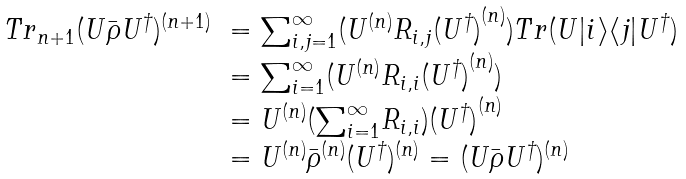<formula> <loc_0><loc_0><loc_500><loc_500>\begin{array} { r l } { T r } _ { n + 1 } ( U { \bar { \rho } } { U ^ { \dagger } } ) ^ { ( n + 1 ) } & = { \sum } _ { i , j = 1 } ^ { \infty } ( U ^ { ( n ) } { R _ { i , j } } { ( U ^ { \dagger } ) } ^ { ( n ) } ) T r ( U { | i \rangle \langle j | } U ^ { \dagger } ) \\ & = { \sum } _ { i = 1 } ^ { \infty } ( U ^ { ( n ) } { R _ { i , i } } { ( U ^ { \dagger } ) } ^ { ( n ) } ) \\ & = U ^ { ( n ) } ( { \sum } _ { i = 1 } ^ { \infty } { R _ { i , i } } ) { ( U ^ { \dagger } ) } ^ { ( n ) } \\ & = U ^ { ( n ) } { \bar { \rho } } ^ { ( n ) } ( U ^ { \dagger } ) ^ { ( n ) } = ( U { \bar { \rho } } { U ^ { \dagger } } ) ^ { ( n ) } \end{array}</formula> 